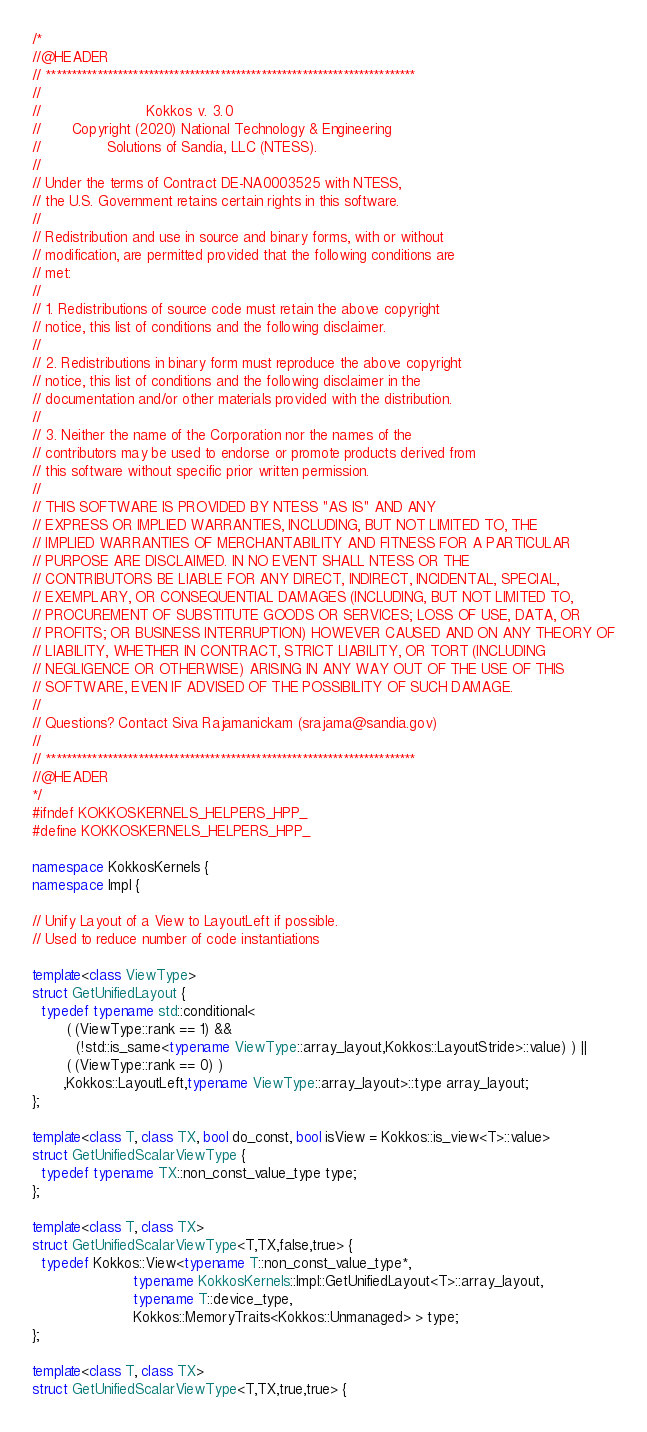<code> <loc_0><loc_0><loc_500><loc_500><_C++_>/*
//@HEADER
// ************************************************************************
//
//                        Kokkos v. 3.0
//       Copyright (2020) National Technology & Engineering
//               Solutions of Sandia, LLC (NTESS).
//
// Under the terms of Contract DE-NA0003525 with NTESS,
// the U.S. Government retains certain rights in this software.
//
// Redistribution and use in source and binary forms, with or without
// modification, are permitted provided that the following conditions are
// met:
//
// 1. Redistributions of source code must retain the above copyright
// notice, this list of conditions and the following disclaimer.
//
// 2. Redistributions in binary form must reproduce the above copyright
// notice, this list of conditions and the following disclaimer in the
// documentation and/or other materials provided with the distribution.
//
// 3. Neither the name of the Corporation nor the names of the
// contributors may be used to endorse or promote products derived from
// this software without specific prior written permission.
//
// THIS SOFTWARE IS PROVIDED BY NTESS "AS IS" AND ANY
// EXPRESS OR IMPLIED WARRANTIES, INCLUDING, BUT NOT LIMITED TO, THE
// IMPLIED WARRANTIES OF MERCHANTABILITY AND FITNESS FOR A PARTICULAR
// PURPOSE ARE DISCLAIMED. IN NO EVENT SHALL NTESS OR THE
// CONTRIBUTORS BE LIABLE FOR ANY DIRECT, INDIRECT, INCIDENTAL, SPECIAL,
// EXEMPLARY, OR CONSEQUENTIAL DAMAGES (INCLUDING, BUT NOT LIMITED TO,
// PROCUREMENT OF SUBSTITUTE GOODS OR SERVICES; LOSS OF USE, DATA, OR
// PROFITS; OR BUSINESS INTERRUPTION) HOWEVER CAUSED AND ON ANY THEORY OF
// LIABILITY, WHETHER IN CONTRACT, STRICT LIABILITY, OR TORT (INCLUDING
// NEGLIGENCE OR OTHERWISE) ARISING IN ANY WAY OUT OF THE USE OF THIS
// SOFTWARE, EVEN IF ADVISED OF THE POSSIBILITY OF SUCH DAMAGE.
//
// Questions? Contact Siva Rajamanickam (srajama@sandia.gov)
//
// ************************************************************************
//@HEADER
*/
#ifndef KOKKOSKERNELS_HELPERS_HPP_
#define KOKKOSKERNELS_HELPERS_HPP_

namespace KokkosKernels {
namespace Impl {

// Unify Layout of a View to LayoutLeft if possible.
// Used to reduce number of code instantiations

template<class ViewType>
struct GetUnifiedLayout {
  typedef typename std::conditional<
        ( (ViewType::rank == 1) &&
          (!std::is_same<typename ViewType::array_layout,Kokkos::LayoutStride>::value) ) ||
        ( (ViewType::rank == 0) )
       ,Kokkos::LayoutLeft,typename ViewType::array_layout>::type array_layout;
};

template<class T, class TX, bool do_const, bool isView = Kokkos::is_view<T>::value>
struct GetUnifiedScalarViewType {
  typedef typename TX::non_const_value_type type;
};

template<class T, class TX>
struct GetUnifiedScalarViewType<T,TX,false,true> {
  typedef Kokkos::View<typename T::non_const_value_type*,
                       typename KokkosKernels::Impl::GetUnifiedLayout<T>::array_layout,
                       typename T::device_type,
                       Kokkos::MemoryTraits<Kokkos::Unmanaged> > type;
};

template<class T, class TX>
struct GetUnifiedScalarViewType<T,TX,true,true> {</code> 